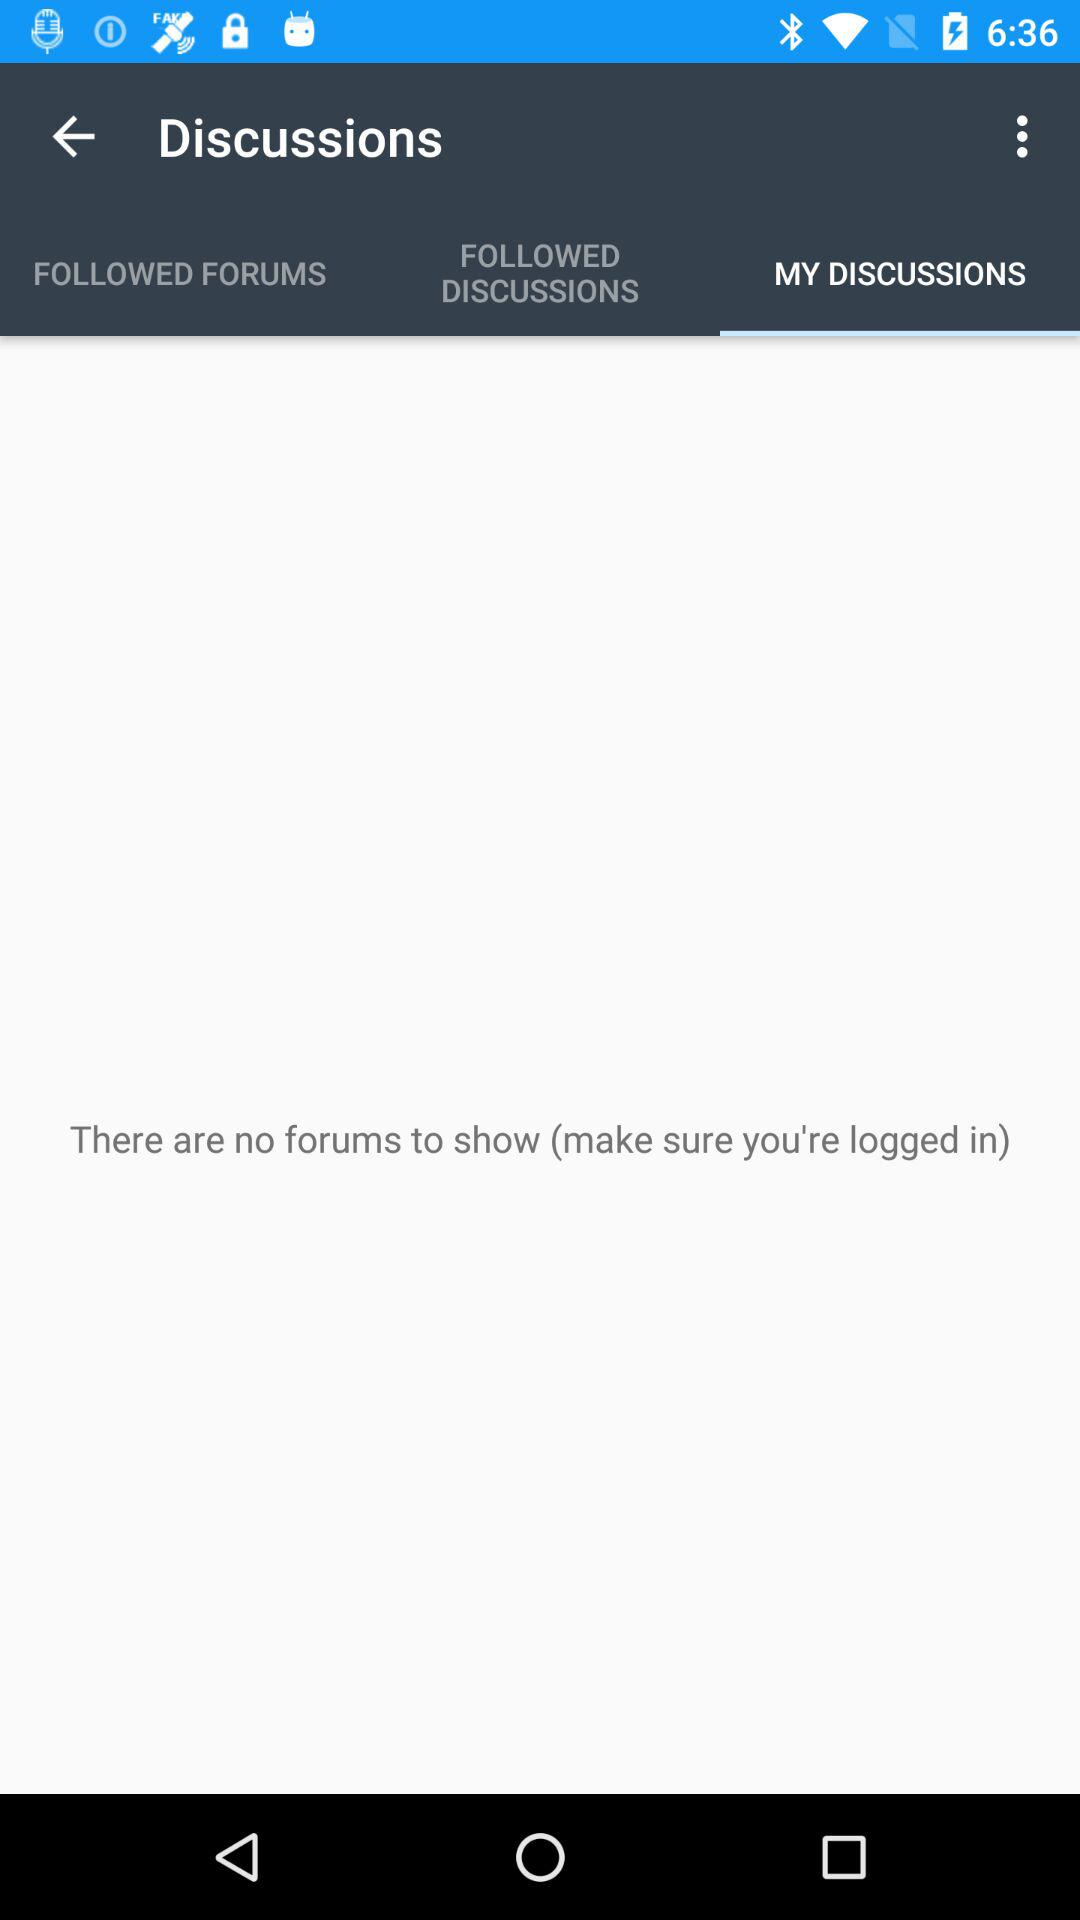How many forums are there to show? There are no forums to show. 